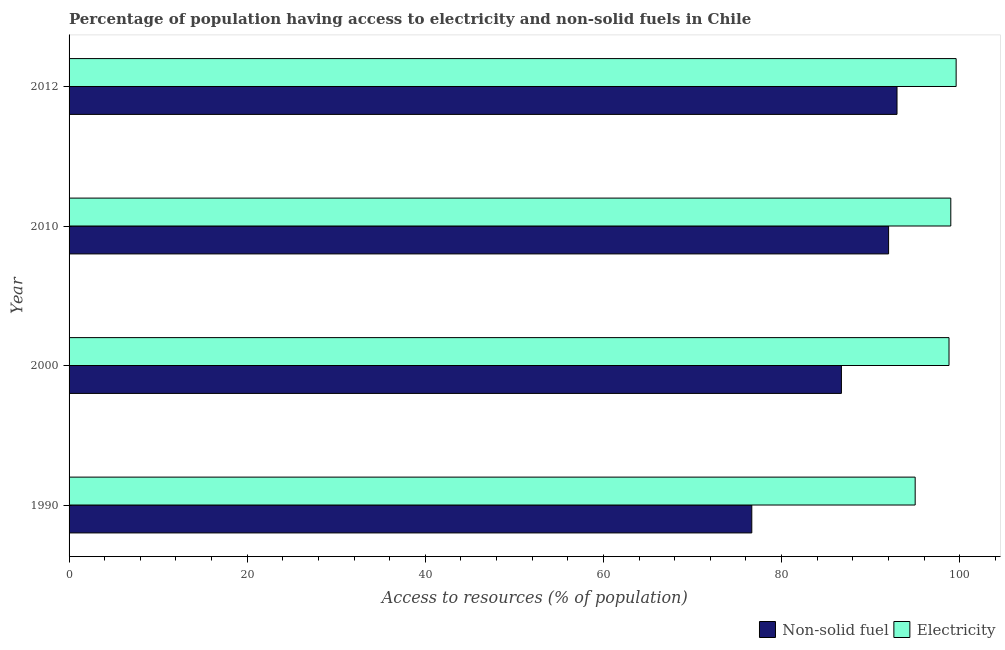How many groups of bars are there?
Provide a succinct answer. 4. Are the number of bars per tick equal to the number of legend labels?
Your answer should be very brief. Yes. How many bars are there on the 2nd tick from the top?
Offer a very short reply. 2. How many bars are there on the 2nd tick from the bottom?
Provide a short and direct response. 2. What is the label of the 1st group of bars from the top?
Provide a succinct answer. 2012. What is the percentage of population having access to non-solid fuel in 1990?
Your response must be concise. 76.66. Across all years, what is the maximum percentage of population having access to non-solid fuel?
Keep it short and to the point. 92.96. Across all years, what is the minimum percentage of population having access to non-solid fuel?
Ensure brevity in your answer.  76.66. What is the total percentage of population having access to non-solid fuel in the graph?
Offer a very short reply. 348.35. What is the difference between the percentage of population having access to non-solid fuel in 2000 and that in 2012?
Provide a succinct answer. -6.24. What is the difference between the percentage of population having access to electricity in 2000 and the percentage of population having access to non-solid fuel in 1990?
Keep it short and to the point. 22.14. What is the average percentage of population having access to non-solid fuel per year?
Keep it short and to the point. 87.09. In the year 2000, what is the difference between the percentage of population having access to non-solid fuel and percentage of population having access to electricity?
Ensure brevity in your answer.  -12.08. In how many years, is the percentage of population having access to electricity greater than 48 %?
Make the answer very short. 4. Is the percentage of population having access to non-solid fuel in 1990 less than that in 2012?
Your answer should be very brief. Yes. Is the difference between the percentage of population having access to electricity in 1990 and 2012 greater than the difference between the percentage of population having access to non-solid fuel in 1990 and 2012?
Ensure brevity in your answer.  Yes. What is the difference between the highest and the second highest percentage of population having access to non-solid fuel?
Your response must be concise. 0.94. What is the difference between the highest and the lowest percentage of population having access to electricity?
Give a very brief answer. 4.6. Is the sum of the percentage of population having access to non-solid fuel in 2000 and 2012 greater than the maximum percentage of population having access to electricity across all years?
Offer a terse response. Yes. What does the 1st bar from the top in 1990 represents?
Give a very brief answer. Electricity. What does the 2nd bar from the bottom in 1990 represents?
Offer a terse response. Electricity. How many bars are there?
Offer a very short reply. 8. How many years are there in the graph?
Offer a terse response. 4. Does the graph contain grids?
Your answer should be compact. No. How many legend labels are there?
Your answer should be very brief. 2. What is the title of the graph?
Give a very brief answer. Percentage of population having access to electricity and non-solid fuels in Chile. Does "External balance on goods" appear as one of the legend labels in the graph?
Keep it short and to the point. No. What is the label or title of the X-axis?
Your response must be concise. Access to resources (% of population). What is the Access to resources (% of population) in Non-solid fuel in 1990?
Ensure brevity in your answer.  76.66. What is the Access to resources (% of population) in Non-solid fuel in 2000?
Provide a succinct answer. 86.72. What is the Access to resources (% of population) of Electricity in 2000?
Your response must be concise. 98.8. What is the Access to resources (% of population) in Non-solid fuel in 2010?
Your response must be concise. 92.02. What is the Access to resources (% of population) of Non-solid fuel in 2012?
Your response must be concise. 92.96. What is the Access to resources (% of population) of Electricity in 2012?
Keep it short and to the point. 99.6. Across all years, what is the maximum Access to resources (% of population) in Non-solid fuel?
Your answer should be compact. 92.96. Across all years, what is the maximum Access to resources (% of population) in Electricity?
Provide a succinct answer. 99.6. Across all years, what is the minimum Access to resources (% of population) of Non-solid fuel?
Your answer should be compact. 76.66. Across all years, what is the minimum Access to resources (% of population) in Electricity?
Your response must be concise. 95. What is the total Access to resources (% of population) of Non-solid fuel in the graph?
Ensure brevity in your answer.  348.35. What is the total Access to resources (% of population) in Electricity in the graph?
Offer a terse response. 392.4. What is the difference between the Access to resources (% of population) of Non-solid fuel in 1990 and that in 2000?
Keep it short and to the point. -10.06. What is the difference between the Access to resources (% of population) of Non-solid fuel in 1990 and that in 2010?
Make the answer very short. -15.36. What is the difference between the Access to resources (% of population) of Non-solid fuel in 1990 and that in 2012?
Your response must be concise. -16.3. What is the difference between the Access to resources (% of population) in Non-solid fuel in 2000 and that in 2010?
Your answer should be very brief. -5.3. What is the difference between the Access to resources (% of population) of Electricity in 2000 and that in 2010?
Keep it short and to the point. -0.2. What is the difference between the Access to resources (% of population) in Non-solid fuel in 2000 and that in 2012?
Provide a short and direct response. -6.24. What is the difference between the Access to resources (% of population) of Non-solid fuel in 2010 and that in 2012?
Your answer should be very brief. -0.94. What is the difference between the Access to resources (% of population) in Non-solid fuel in 1990 and the Access to resources (% of population) in Electricity in 2000?
Make the answer very short. -22.14. What is the difference between the Access to resources (% of population) in Non-solid fuel in 1990 and the Access to resources (% of population) in Electricity in 2010?
Your response must be concise. -22.34. What is the difference between the Access to resources (% of population) of Non-solid fuel in 1990 and the Access to resources (% of population) of Electricity in 2012?
Offer a very short reply. -22.94. What is the difference between the Access to resources (% of population) in Non-solid fuel in 2000 and the Access to resources (% of population) in Electricity in 2010?
Offer a terse response. -12.28. What is the difference between the Access to resources (% of population) of Non-solid fuel in 2000 and the Access to resources (% of population) of Electricity in 2012?
Give a very brief answer. -12.88. What is the difference between the Access to resources (% of population) of Non-solid fuel in 2010 and the Access to resources (% of population) of Electricity in 2012?
Offer a terse response. -7.58. What is the average Access to resources (% of population) of Non-solid fuel per year?
Make the answer very short. 87.09. What is the average Access to resources (% of population) of Electricity per year?
Offer a terse response. 98.1. In the year 1990, what is the difference between the Access to resources (% of population) of Non-solid fuel and Access to resources (% of population) of Electricity?
Provide a short and direct response. -18.34. In the year 2000, what is the difference between the Access to resources (% of population) of Non-solid fuel and Access to resources (% of population) of Electricity?
Keep it short and to the point. -12.08. In the year 2010, what is the difference between the Access to resources (% of population) in Non-solid fuel and Access to resources (% of population) in Electricity?
Your response must be concise. -6.98. In the year 2012, what is the difference between the Access to resources (% of population) in Non-solid fuel and Access to resources (% of population) in Electricity?
Provide a succinct answer. -6.64. What is the ratio of the Access to resources (% of population) in Non-solid fuel in 1990 to that in 2000?
Keep it short and to the point. 0.88. What is the ratio of the Access to resources (% of population) of Electricity in 1990 to that in 2000?
Keep it short and to the point. 0.96. What is the ratio of the Access to resources (% of population) of Non-solid fuel in 1990 to that in 2010?
Your answer should be compact. 0.83. What is the ratio of the Access to resources (% of population) of Electricity in 1990 to that in 2010?
Ensure brevity in your answer.  0.96. What is the ratio of the Access to resources (% of population) of Non-solid fuel in 1990 to that in 2012?
Your answer should be very brief. 0.82. What is the ratio of the Access to resources (% of population) in Electricity in 1990 to that in 2012?
Your response must be concise. 0.95. What is the ratio of the Access to resources (% of population) in Non-solid fuel in 2000 to that in 2010?
Ensure brevity in your answer.  0.94. What is the ratio of the Access to resources (% of population) of Electricity in 2000 to that in 2010?
Make the answer very short. 1. What is the ratio of the Access to resources (% of population) in Non-solid fuel in 2000 to that in 2012?
Give a very brief answer. 0.93. What is the ratio of the Access to resources (% of population) in Electricity in 2000 to that in 2012?
Make the answer very short. 0.99. What is the ratio of the Access to resources (% of population) in Electricity in 2010 to that in 2012?
Your response must be concise. 0.99. What is the difference between the highest and the second highest Access to resources (% of population) of Non-solid fuel?
Your response must be concise. 0.94. What is the difference between the highest and the lowest Access to resources (% of population) in Non-solid fuel?
Offer a very short reply. 16.3. 